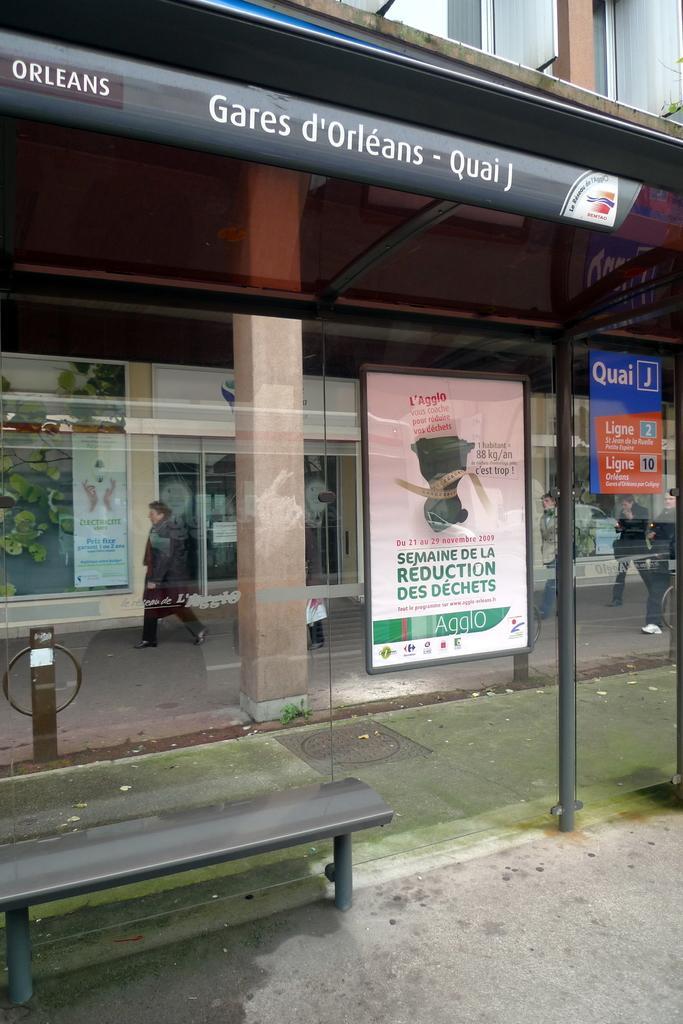How would you summarize this image in a sentence or two? In this image we can see a group of people walking on the ground. We can also see a bench, glass window, some boards with text on them, a pillar and a roof. On the backside we can see a building. 